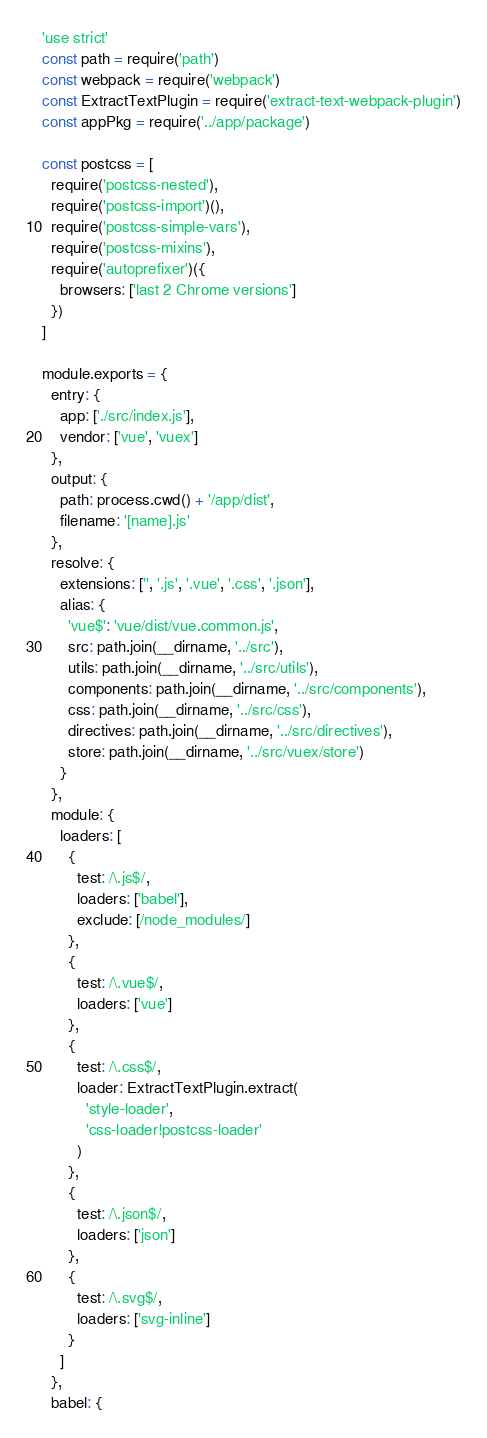<code> <loc_0><loc_0><loc_500><loc_500><_JavaScript_>'use strict'
const path = require('path')
const webpack = require('webpack')
const ExtractTextPlugin = require('extract-text-webpack-plugin')
const appPkg = require('../app/package')

const postcss = [
  require('postcss-nested'),
  require('postcss-import')(),
  require('postcss-simple-vars'),
  require('postcss-mixins'),
  require('autoprefixer')({
    browsers: ['last 2 Chrome versions']
  })
]

module.exports = {
  entry: {
    app: ['./src/index.js'],
    vendor: ['vue', 'vuex']
  },
  output: {
    path: process.cwd() + '/app/dist',
    filename: '[name].js'
  },
  resolve: {
    extensions: ['', '.js', '.vue', '.css', '.json'],
    alias: {
      'vue$': 'vue/dist/vue.common.js',
      src: path.join(__dirname, '../src'),
      utils: path.join(__dirname, '../src/utils'),
      components: path.join(__dirname, '../src/components'),
      css: path.join(__dirname, '../src/css'),
      directives: path.join(__dirname, '../src/directives'),
      store: path.join(__dirname, '../src/vuex/store')
    }
  },
  module: {
    loaders: [
      {
        test: /\.js$/,
        loaders: ['babel'],
        exclude: [/node_modules/]
      },
      {
        test: /\.vue$/,
        loaders: ['vue']
      },
      {
        test: /\.css$/,
        loader: ExtractTextPlugin.extract(
          'style-loader',
          'css-loader!postcss-loader'
        )
      },
      {
        test: /\.json$/,
        loaders: ['json']
      },
      {
        test: /\.svg$/,
        loaders: ['svg-inline']
      }
    ]
  },
  babel: {</code> 